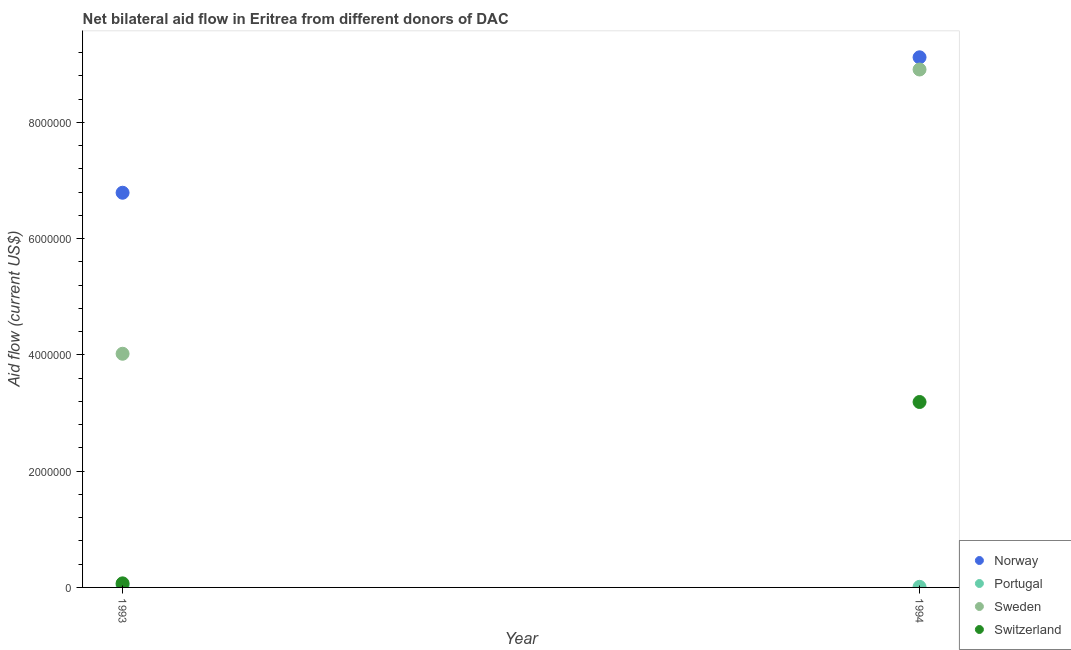How many different coloured dotlines are there?
Provide a succinct answer. 4. Is the number of dotlines equal to the number of legend labels?
Give a very brief answer. Yes. What is the amount of aid given by switzerland in 1994?
Keep it short and to the point. 3.19e+06. Across all years, what is the maximum amount of aid given by norway?
Make the answer very short. 9.12e+06. Across all years, what is the minimum amount of aid given by norway?
Provide a succinct answer. 6.79e+06. In which year was the amount of aid given by portugal maximum?
Your answer should be very brief. 1993. In which year was the amount of aid given by sweden minimum?
Offer a terse response. 1993. What is the total amount of aid given by sweden in the graph?
Offer a terse response. 1.29e+07. What is the difference between the amount of aid given by sweden in 1993 and that in 1994?
Provide a succinct answer. -4.89e+06. What is the difference between the amount of aid given by switzerland in 1994 and the amount of aid given by sweden in 1993?
Provide a succinct answer. -8.30e+05. What is the average amount of aid given by sweden per year?
Offer a terse response. 6.46e+06. In the year 1993, what is the difference between the amount of aid given by switzerland and amount of aid given by norway?
Keep it short and to the point. -6.72e+06. What is the ratio of the amount of aid given by norway in 1993 to that in 1994?
Offer a very short reply. 0.74. Is the amount of aid given by norway in 1993 less than that in 1994?
Make the answer very short. Yes. Is it the case that in every year, the sum of the amount of aid given by portugal and amount of aid given by switzerland is greater than the sum of amount of aid given by norway and amount of aid given by sweden?
Provide a succinct answer. No. Is it the case that in every year, the sum of the amount of aid given by norway and amount of aid given by portugal is greater than the amount of aid given by sweden?
Provide a short and direct response. Yes. Is the amount of aid given by switzerland strictly less than the amount of aid given by norway over the years?
Provide a succinct answer. Yes. How many years are there in the graph?
Provide a succinct answer. 2. What is the difference between two consecutive major ticks on the Y-axis?
Keep it short and to the point. 2.00e+06. Where does the legend appear in the graph?
Offer a terse response. Bottom right. What is the title of the graph?
Your response must be concise. Net bilateral aid flow in Eritrea from different donors of DAC. What is the label or title of the Y-axis?
Your answer should be very brief. Aid flow (current US$). What is the Aid flow (current US$) of Norway in 1993?
Give a very brief answer. 6.79e+06. What is the Aid flow (current US$) in Sweden in 1993?
Make the answer very short. 4.02e+06. What is the Aid flow (current US$) of Switzerland in 1993?
Give a very brief answer. 7.00e+04. What is the Aid flow (current US$) in Norway in 1994?
Make the answer very short. 9.12e+06. What is the Aid flow (current US$) in Sweden in 1994?
Ensure brevity in your answer.  8.91e+06. What is the Aid flow (current US$) in Switzerland in 1994?
Keep it short and to the point. 3.19e+06. Across all years, what is the maximum Aid flow (current US$) in Norway?
Your response must be concise. 9.12e+06. Across all years, what is the maximum Aid flow (current US$) in Portugal?
Keep it short and to the point. 4.00e+04. Across all years, what is the maximum Aid flow (current US$) in Sweden?
Ensure brevity in your answer.  8.91e+06. Across all years, what is the maximum Aid flow (current US$) in Switzerland?
Your answer should be very brief. 3.19e+06. Across all years, what is the minimum Aid flow (current US$) in Norway?
Your answer should be compact. 6.79e+06. Across all years, what is the minimum Aid flow (current US$) of Sweden?
Make the answer very short. 4.02e+06. What is the total Aid flow (current US$) of Norway in the graph?
Keep it short and to the point. 1.59e+07. What is the total Aid flow (current US$) of Portugal in the graph?
Offer a very short reply. 5.00e+04. What is the total Aid flow (current US$) of Sweden in the graph?
Your response must be concise. 1.29e+07. What is the total Aid flow (current US$) of Switzerland in the graph?
Ensure brevity in your answer.  3.26e+06. What is the difference between the Aid flow (current US$) of Norway in 1993 and that in 1994?
Keep it short and to the point. -2.33e+06. What is the difference between the Aid flow (current US$) of Sweden in 1993 and that in 1994?
Provide a short and direct response. -4.89e+06. What is the difference between the Aid flow (current US$) in Switzerland in 1993 and that in 1994?
Your answer should be compact. -3.12e+06. What is the difference between the Aid flow (current US$) of Norway in 1993 and the Aid flow (current US$) of Portugal in 1994?
Provide a succinct answer. 6.78e+06. What is the difference between the Aid flow (current US$) of Norway in 1993 and the Aid flow (current US$) of Sweden in 1994?
Your answer should be very brief. -2.12e+06. What is the difference between the Aid flow (current US$) in Norway in 1993 and the Aid flow (current US$) in Switzerland in 1994?
Your answer should be compact. 3.60e+06. What is the difference between the Aid flow (current US$) in Portugal in 1993 and the Aid flow (current US$) in Sweden in 1994?
Make the answer very short. -8.87e+06. What is the difference between the Aid flow (current US$) in Portugal in 1993 and the Aid flow (current US$) in Switzerland in 1994?
Offer a terse response. -3.15e+06. What is the difference between the Aid flow (current US$) of Sweden in 1993 and the Aid flow (current US$) of Switzerland in 1994?
Provide a succinct answer. 8.30e+05. What is the average Aid flow (current US$) in Norway per year?
Offer a terse response. 7.96e+06. What is the average Aid flow (current US$) of Portugal per year?
Offer a very short reply. 2.50e+04. What is the average Aid flow (current US$) in Sweden per year?
Provide a succinct answer. 6.46e+06. What is the average Aid flow (current US$) in Switzerland per year?
Offer a terse response. 1.63e+06. In the year 1993, what is the difference between the Aid flow (current US$) of Norway and Aid flow (current US$) of Portugal?
Offer a terse response. 6.75e+06. In the year 1993, what is the difference between the Aid flow (current US$) in Norway and Aid flow (current US$) in Sweden?
Provide a short and direct response. 2.77e+06. In the year 1993, what is the difference between the Aid flow (current US$) in Norway and Aid flow (current US$) in Switzerland?
Provide a short and direct response. 6.72e+06. In the year 1993, what is the difference between the Aid flow (current US$) in Portugal and Aid flow (current US$) in Sweden?
Your answer should be compact. -3.98e+06. In the year 1993, what is the difference between the Aid flow (current US$) in Portugal and Aid flow (current US$) in Switzerland?
Offer a terse response. -3.00e+04. In the year 1993, what is the difference between the Aid flow (current US$) in Sweden and Aid flow (current US$) in Switzerland?
Your response must be concise. 3.95e+06. In the year 1994, what is the difference between the Aid flow (current US$) in Norway and Aid flow (current US$) in Portugal?
Keep it short and to the point. 9.11e+06. In the year 1994, what is the difference between the Aid flow (current US$) in Norway and Aid flow (current US$) in Switzerland?
Your response must be concise. 5.93e+06. In the year 1994, what is the difference between the Aid flow (current US$) in Portugal and Aid flow (current US$) in Sweden?
Make the answer very short. -8.90e+06. In the year 1994, what is the difference between the Aid flow (current US$) in Portugal and Aid flow (current US$) in Switzerland?
Provide a short and direct response. -3.18e+06. In the year 1994, what is the difference between the Aid flow (current US$) in Sweden and Aid flow (current US$) in Switzerland?
Give a very brief answer. 5.72e+06. What is the ratio of the Aid flow (current US$) of Norway in 1993 to that in 1994?
Keep it short and to the point. 0.74. What is the ratio of the Aid flow (current US$) in Sweden in 1993 to that in 1994?
Offer a terse response. 0.45. What is the ratio of the Aid flow (current US$) in Switzerland in 1993 to that in 1994?
Your answer should be very brief. 0.02. What is the difference between the highest and the second highest Aid flow (current US$) of Norway?
Your answer should be compact. 2.33e+06. What is the difference between the highest and the second highest Aid flow (current US$) of Portugal?
Give a very brief answer. 3.00e+04. What is the difference between the highest and the second highest Aid flow (current US$) of Sweden?
Your response must be concise. 4.89e+06. What is the difference between the highest and the second highest Aid flow (current US$) of Switzerland?
Your response must be concise. 3.12e+06. What is the difference between the highest and the lowest Aid flow (current US$) in Norway?
Offer a terse response. 2.33e+06. What is the difference between the highest and the lowest Aid flow (current US$) in Portugal?
Give a very brief answer. 3.00e+04. What is the difference between the highest and the lowest Aid flow (current US$) of Sweden?
Your answer should be compact. 4.89e+06. What is the difference between the highest and the lowest Aid flow (current US$) of Switzerland?
Your answer should be compact. 3.12e+06. 